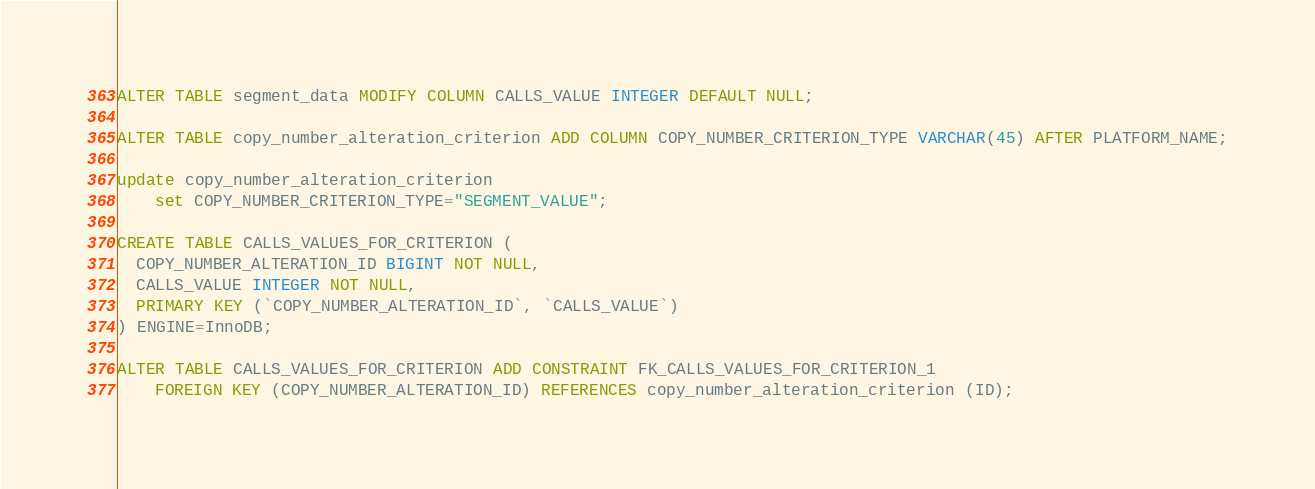Convert code to text. <code><loc_0><loc_0><loc_500><loc_500><_SQL_>ALTER TABLE segment_data MODIFY COLUMN CALLS_VALUE INTEGER DEFAULT NULL;

ALTER TABLE copy_number_alteration_criterion ADD COLUMN COPY_NUMBER_CRITERION_TYPE VARCHAR(45) AFTER PLATFORM_NAME;

update copy_number_alteration_criterion 
    set COPY_NUMBER_CRITERION_TYPE="SEGMENT_VALUE";
    
CREATE TABLE CALLS_VALUES_FOR_CRITERION (
  COPY_NUMBER_ALTERATION_ID BIGINT NOT NULL,
  CALLS_VALUE INTEGER NOT NULL,
  PRIMARY KEY (`COPY_NUMBER_ALTERATION_ID`, `CALLS_VALUE`)
) ENGINE=InnoDB;

ALTER TABLE CALLS_VALUES_FOR_CRITERION ADD CONSTRAINT FK_CALLS_VALUES_FOR_CRITERION_1 
    FOREIGN KEY (COPY_NUMBER_ALTERATION_ID) REFERENCES copy_number_alteration_criterion (ID);
</code> 